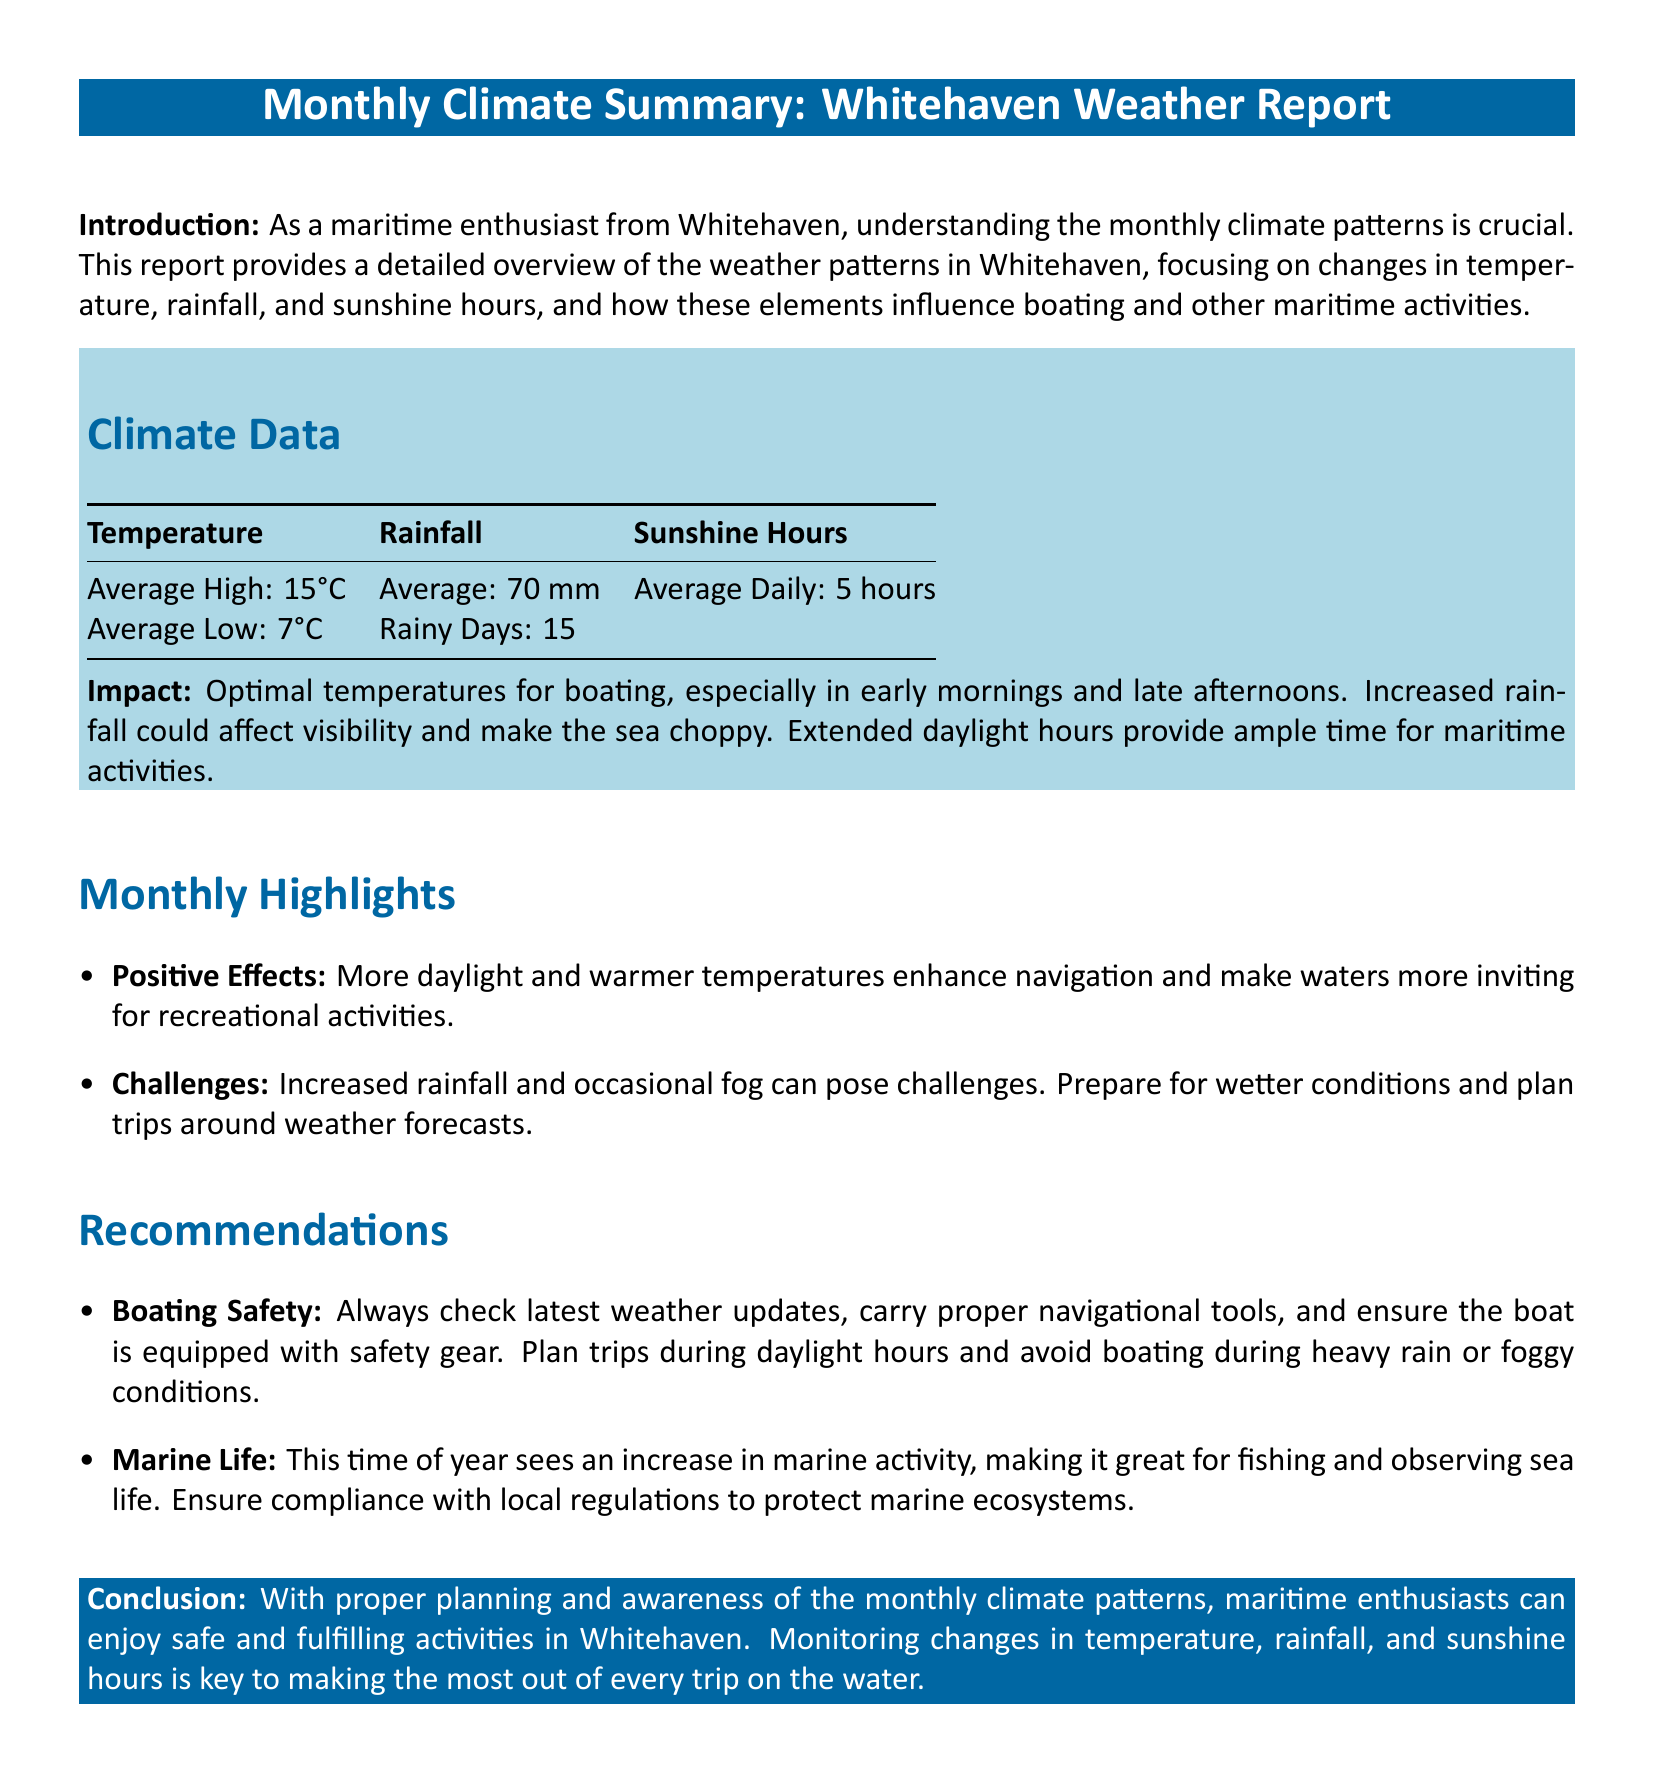What is the average high temperature in Whitehaven? The average high temperature is provided in the climate data section.
Answer: 15°C How many rainy days are noted in the summary? The number of rainy days is specifically listed in the climate data table.
Answer: 15 What is the average daily sunshine in hours? The average daily sunshine hours are mentioned in the climate data section.
Answer: 5 hours What potential challenge is mentioned for maritime activities? The report highlights specific challenges associated with weather conditions affecting maritime pursuits.
Answer: Increased rainfall What is recommended for boating safety? The recommendations section outlines specific actions to ensure boating safety.
Answer: Check latest weather updates How does the summary suggest the change in temperature affects boating? The impact section discusses the relationship between temperature and boating conditions.
Answer: Optimal temperatures for boating What marine activity increases during this month? The recommendations indicate a specific increase in activity relevant to maritime enthusiasts.
Answer: Fishing What is a key aspect to monitor for safe maritime activities? The conclusion emphasizes the importance of one particular factor for safe boating.
Answer: Changes in temperature How does extended daylight influence maritime activities? The impact section describes the effects of more daylight on boating opportunities.
Answer: Provides ample time for maritime activities 